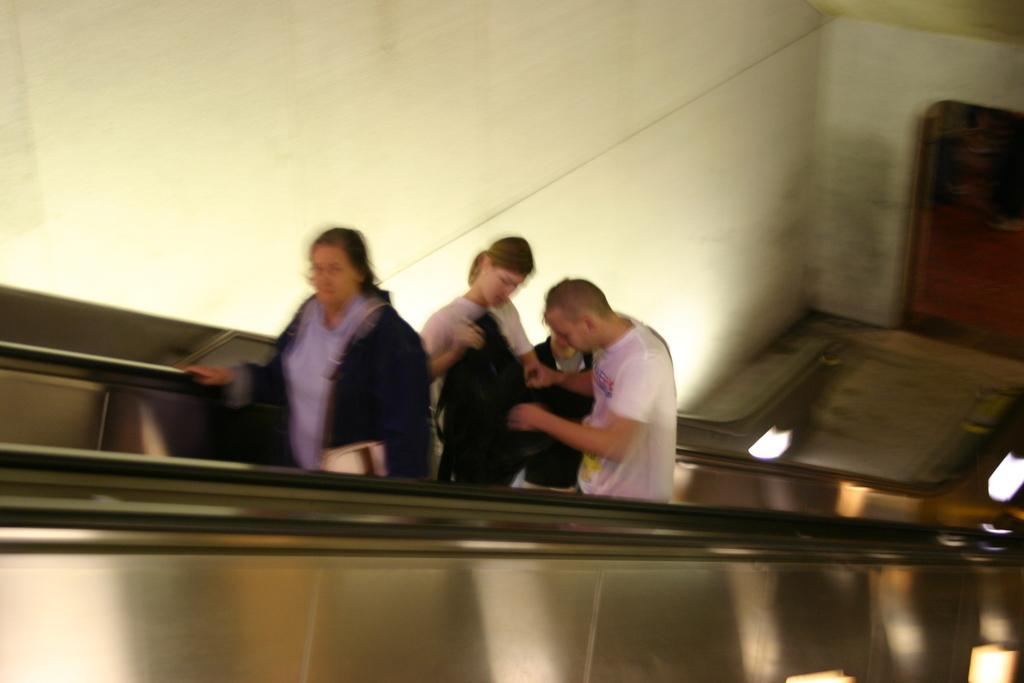Could you give a brief overview of what you see in this image? In the foreground I can see four persons are standing on the staircase. In the background I can see a wall and a door. This image is taken in a building. 